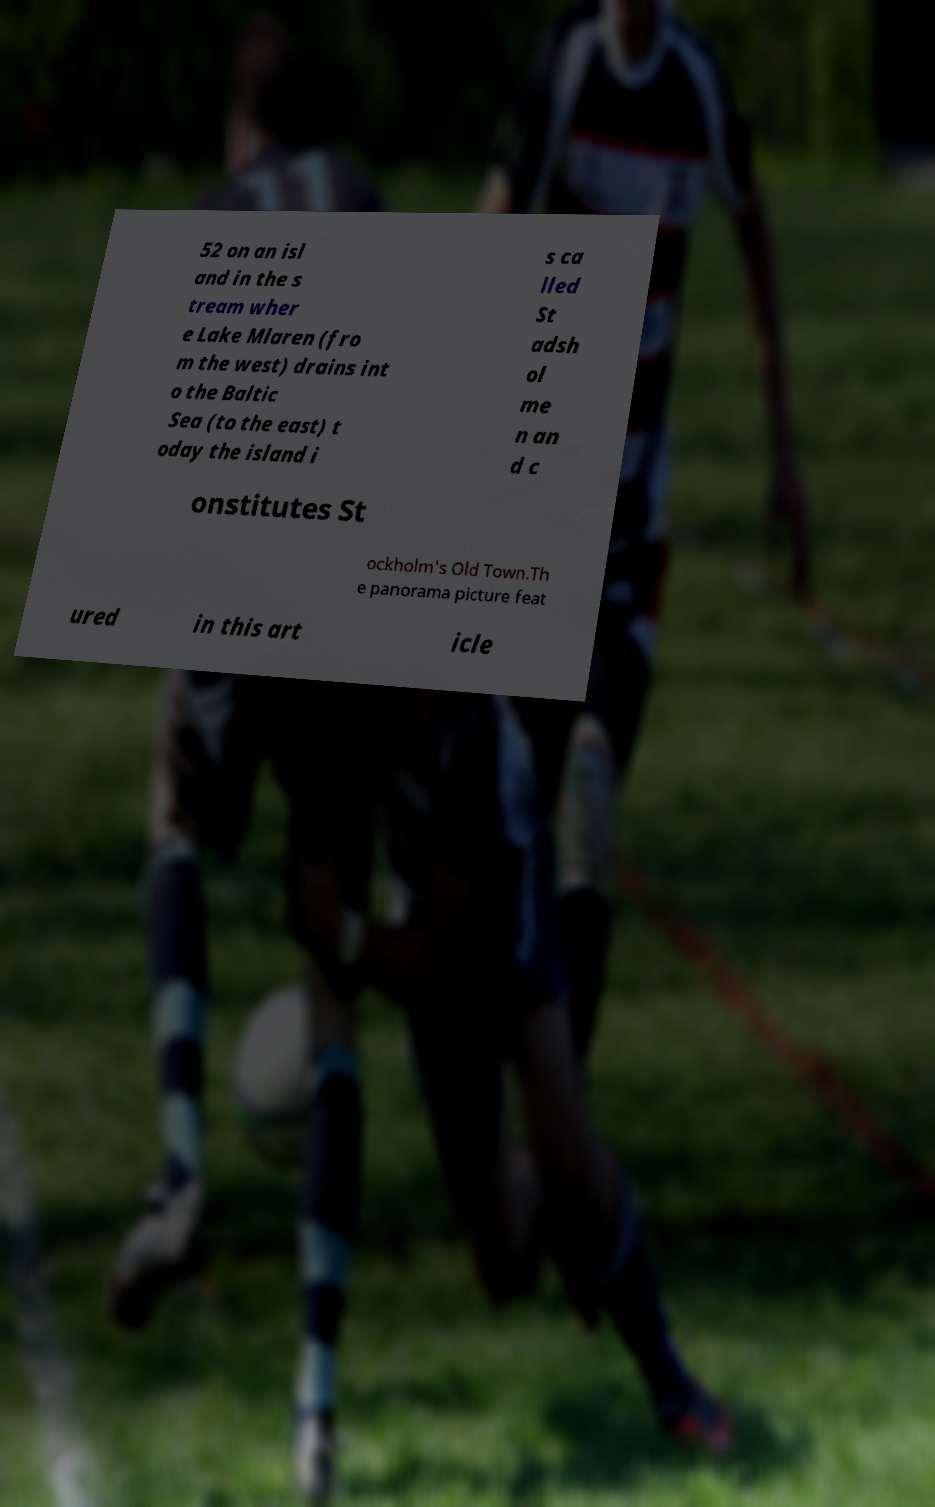Could you assist in decoding the text presented in this image and type it out clearly? 52 on an isl and in the s tream wher e Lake Mlaren (fro m the west) drains int o the Baltic Sea (to the east) t oday the island i s ca lled St adsh ol me n an d c onstitutes St ockholm's Old Town.Th e panorama picture feat ured in this art icle 